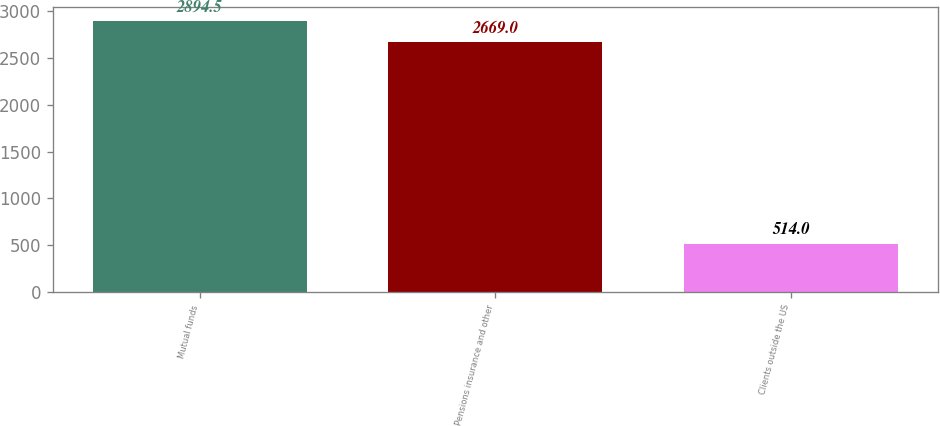Convert chart to OTSL. <chart><loc_0><loc_0><loc_500><loc_500><bar_chart><fcel>Mutual funds<fcel>Pensions insurance and other<fcel>Clients outside the US<nl><fcel>2894.5<fcel>2669<fcel>514<nl></chart> 